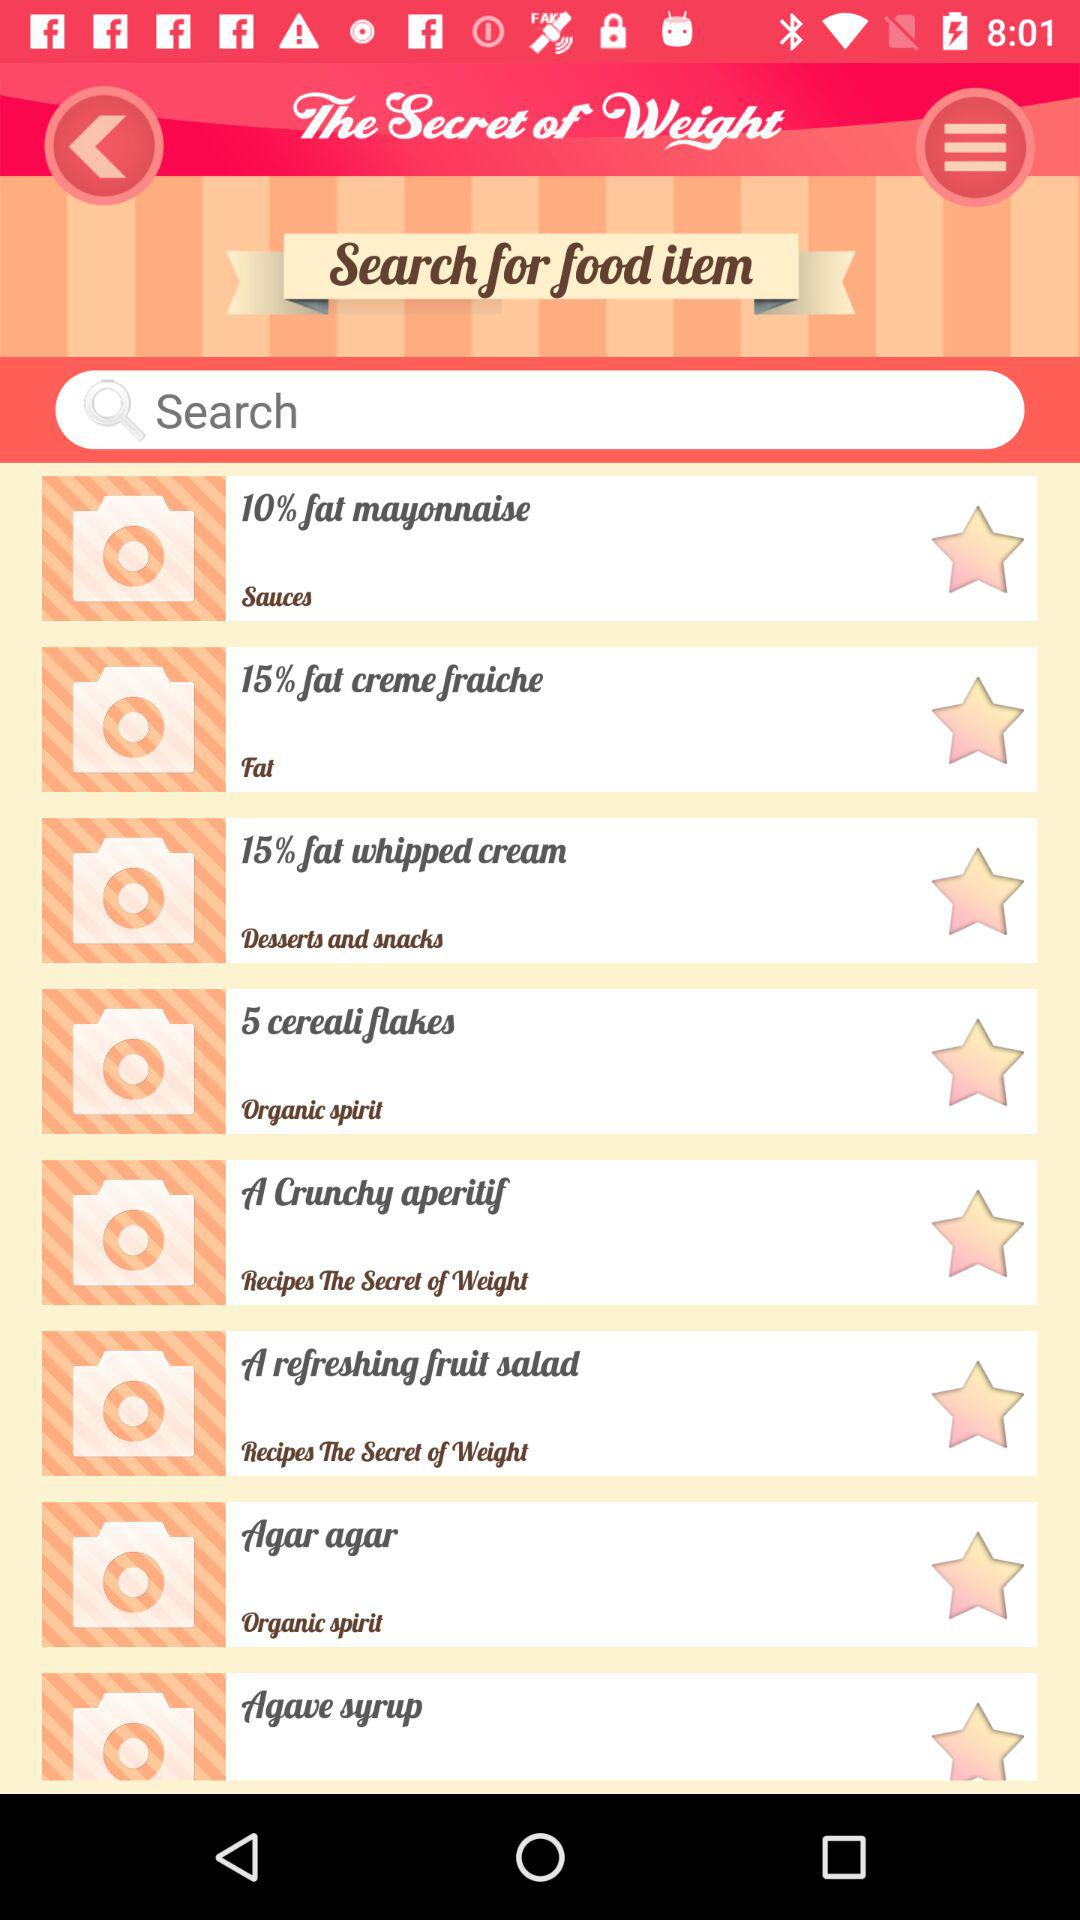How many are off for sauces?
When the provided information is insufficient, respond with <no answer>. <no answer> 